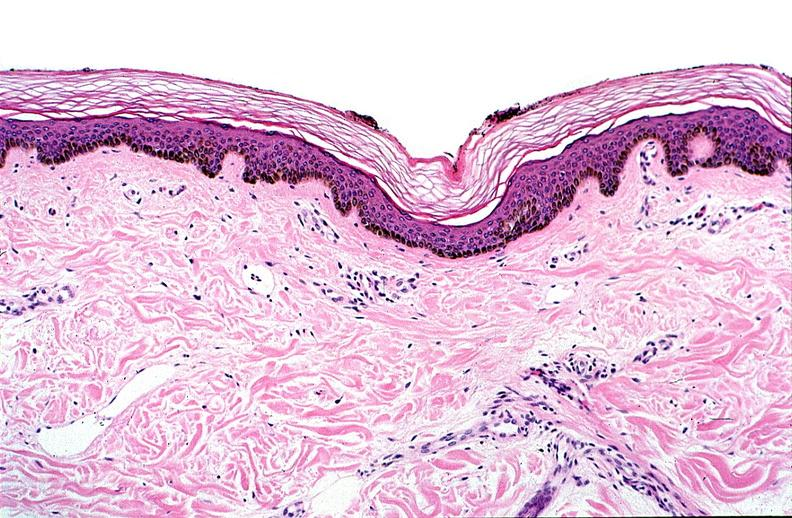does this image show thermal burned skin?
Answer the question using a single word or phrase. Yes 